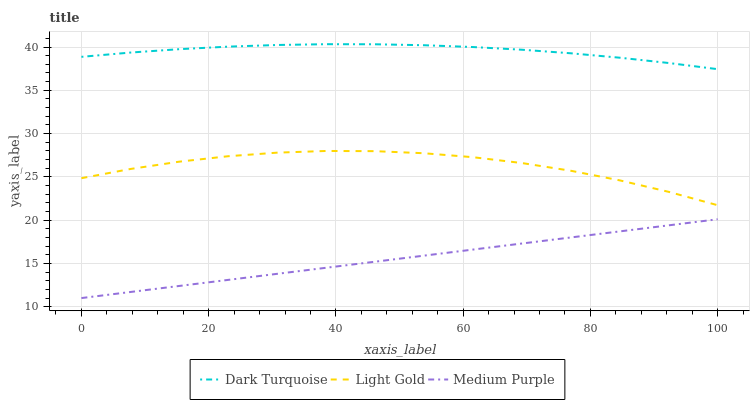Does Medium Purple have the minimum area under the curve?
Answer yes or no. Yes. Does Dark Turquoise have the maximum area under the curve?
Answer yes or no. Yes. Does Light Gold have the minimum area under the curve?
Answer yes or no. No. Does Light Gold have the maximum area under the curve?
Answer yes or no. No. Is Medium Purple the smoothest?
Answer yes or no. Yes. Is Light Gold the roughest?
Answer yes or no. Yes. Is Dark Turquoise the smoothest?
Answer yes or no. No. Is Dark Turquoise the roughest?
Answer yes or no. No. Does Medium Purple have the lowest value?
Answer yes or no. Yes. Does Light Gold have the lowest value?
Answer yes or no. No. Does Dark Turquoise have the highest value?
Answer yes or no. Yes. Does Light Gold have the highest value?
Answer yes or no. No. Is Medium Purple less than Light Gold?
Answer yes or no. Yes. Is Dark Turquoise greater than Light Gold?
Answer yes or no. Yes. Does Medium Purple intersect Light Gold?
Answer yes or no. No. 